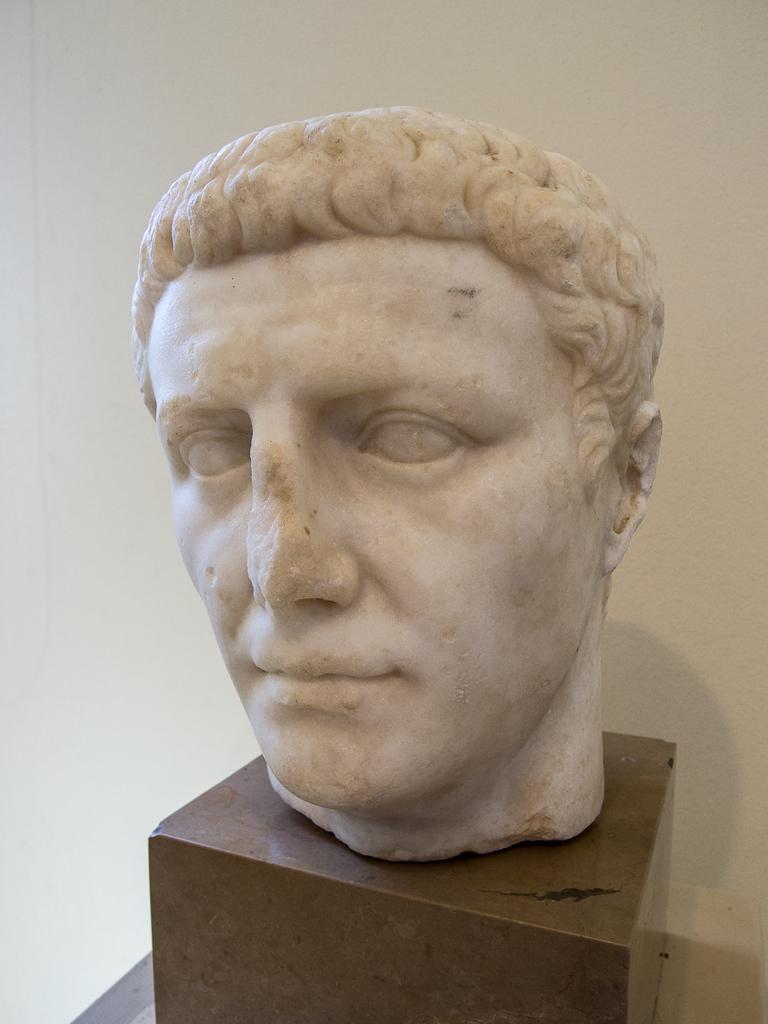Could you give a brief overview of what you see in this image? In this image we can see a sculpture placed on the stand. In the background there is a wall. 